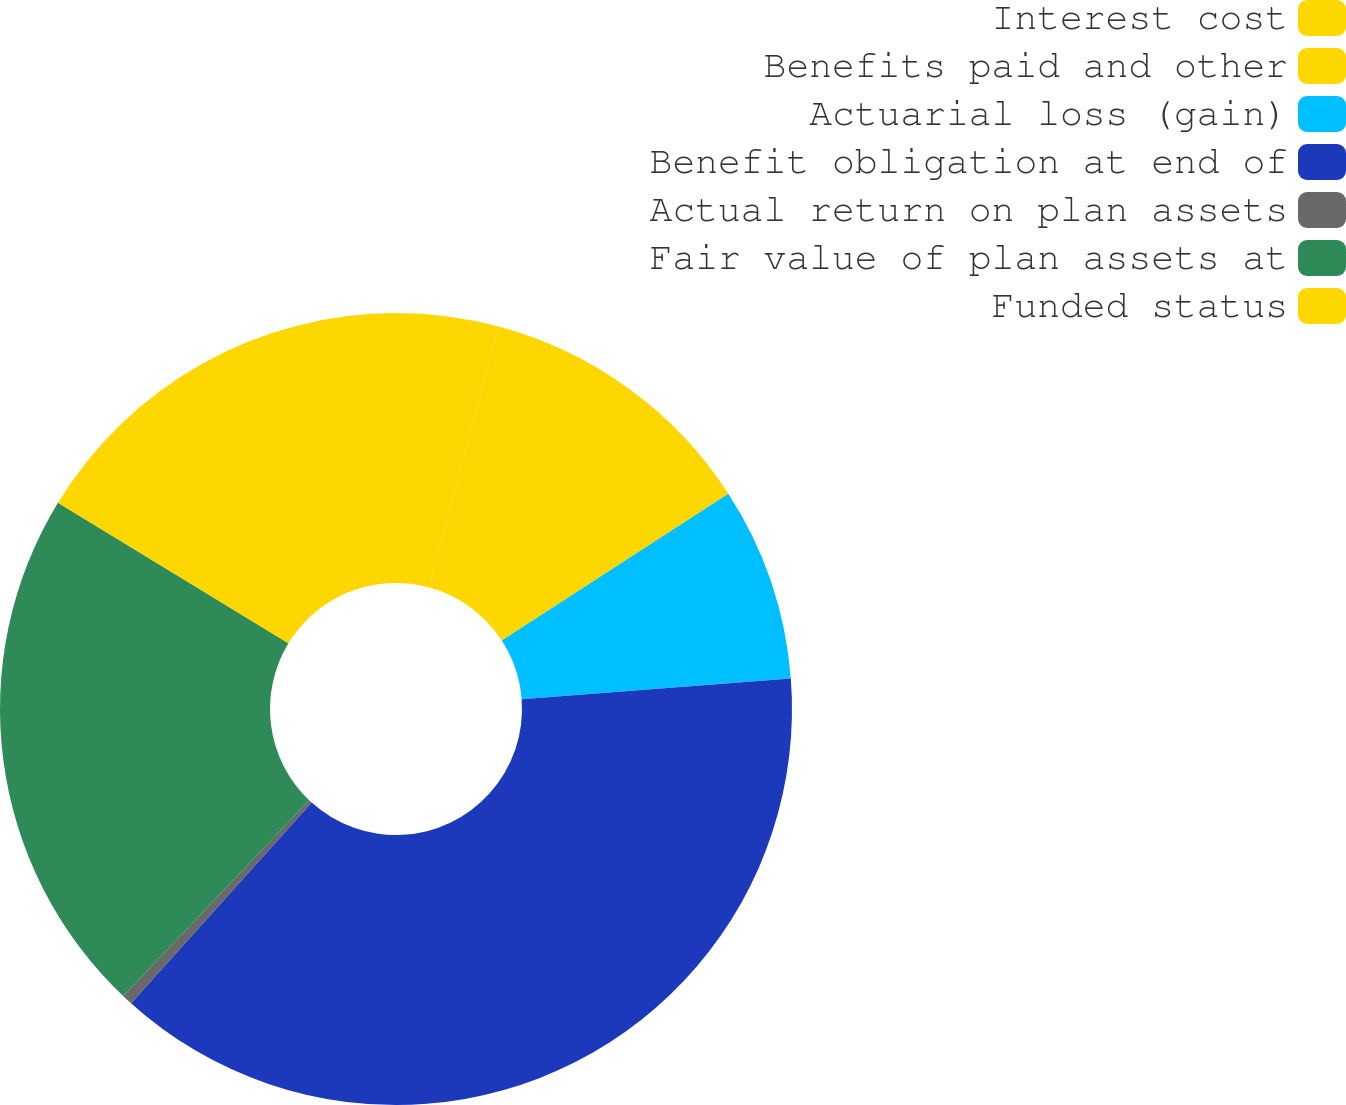Convert chart to OTSL. <chart><loc_0><loc_0><loc_500><loc_500><pie_chart><fcel>Interest cost<fcel>Benefits paid and other<fcel>Actuarial loss (gain)<fcel>Benefit obligation at end of<fcel>Actual return on plan assets<fcel>Fair value of plan assets at<fcel>Funded status<nl><fcel>4.18%<fcel>11.67%<fcel>7.92%<fcel>37.9%<fcel>0.43%<fcel>21.62%<fcel>16.28%<nl></chart> 